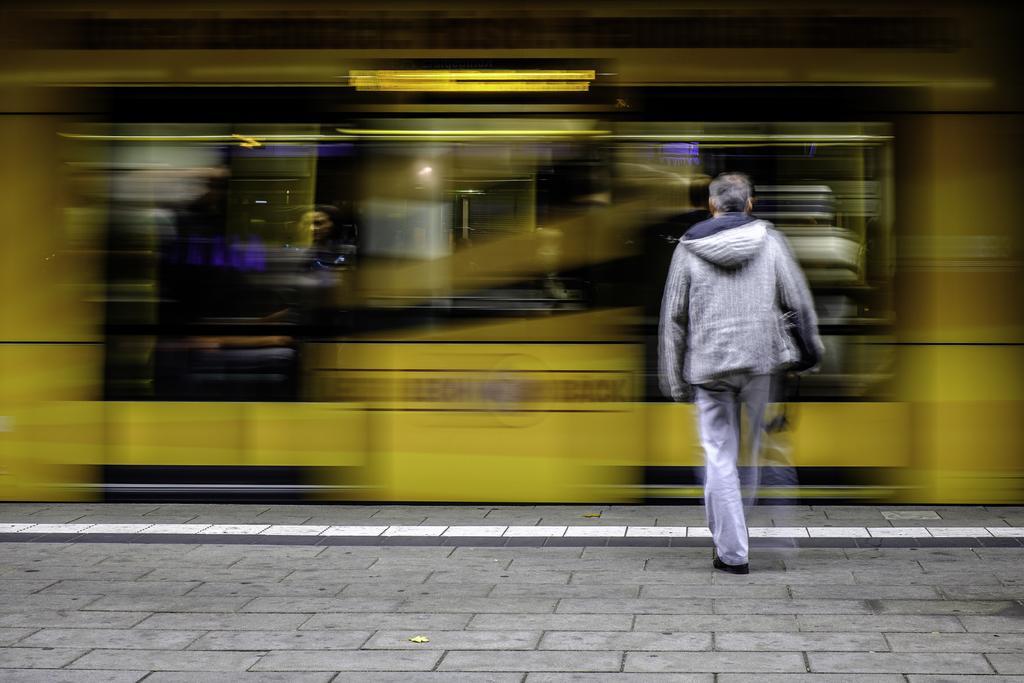Describe this image in one or two sentences. In this picture there is a man on the right side of the image and the background area of the image is blur. 